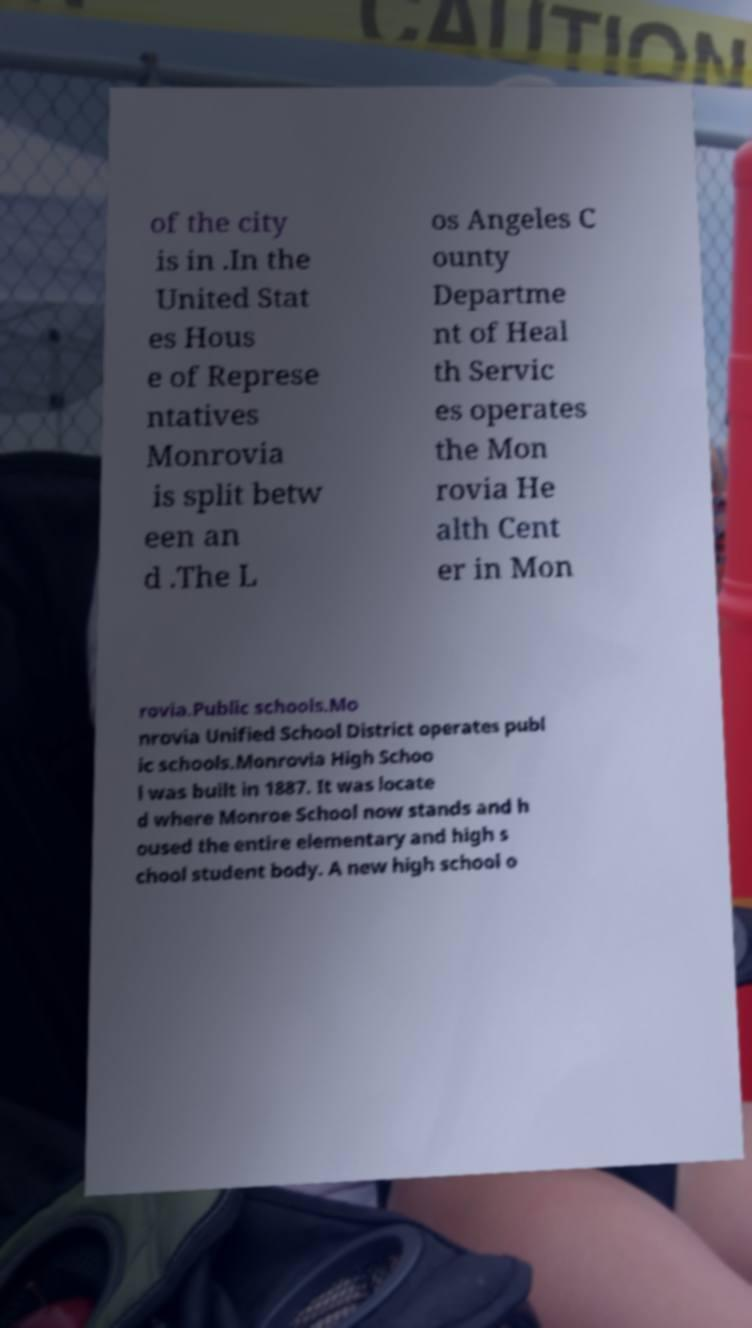What messages or text are displayed in this image? I need them in a readable, typed format. of the city is in .In the United Stat es Hous e of Represe ntatives Monrovia is split betw een an d .The L os Angeles C ounty Departme nt of Heal th Servic es operates the Mon rovia He alth Cent er in Mon rovia.Public schools.Mo nrovia Unified School District operates publ ic schools.Monrovia High Schoo l was built in 1887. It was locate d where Monroe School now stands and h oused the entire elementary and high s chool student body. A new high school o 